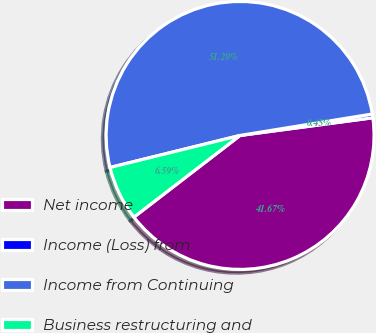Convert chart to OTSL. <chart><loc_0><loc_0><loc_500><loc_500><pie_chart><fcel>Net income<fcel>Income (Loss) from<fcel>Income from Continuing<fcel>Business restructuring and<nl><fcel>41.67%<fcel>0.45%<fcel>51.29%<fcel>6.59%<nl></chart> 